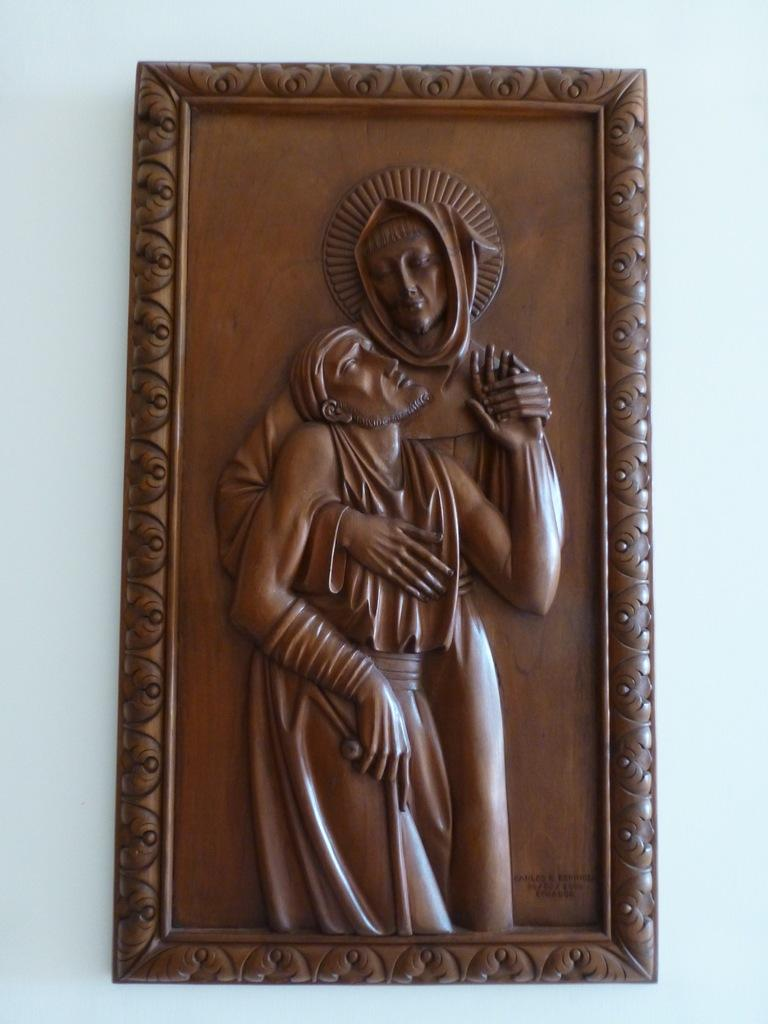What is the main subject of the image? There is a sculpture in the image. What material is the sculpture made of? The sculpture is made of wood. Where is the sculpture located in the image? The sculpture is placed on the wall. What type of channel can be seen running through the sculpture in the image? There is no channel visible in the sculpture, as it is made of wood and does not have any visible openings or pathways. 